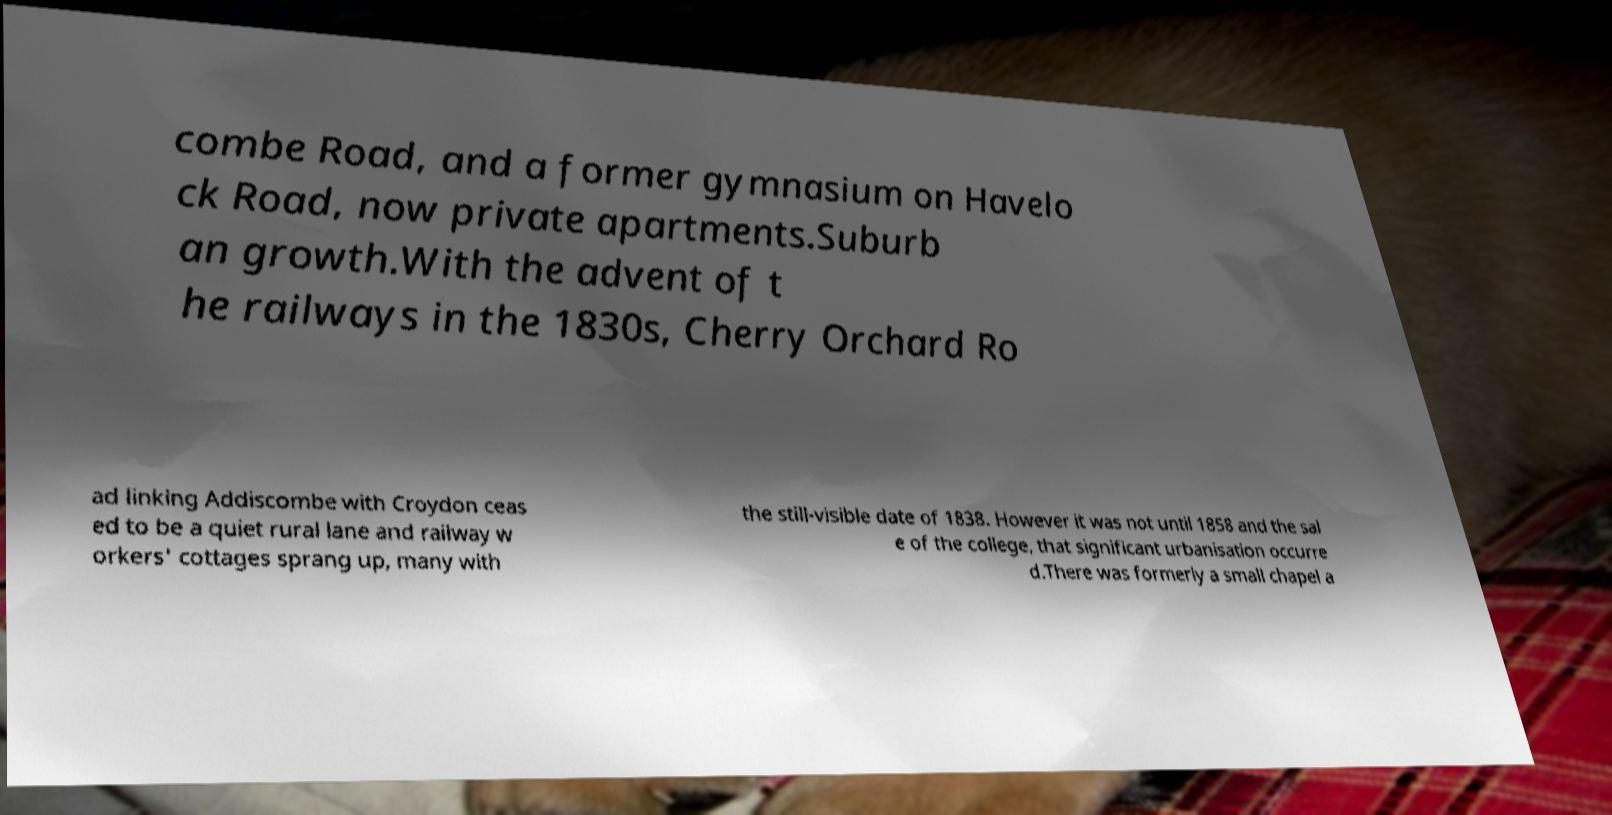For documentation purposes, I need the text within this image transcribed. Could you provide that? combe Road, and a former gymnasium on Havelo ck Road, now private apartments.Suburb an growth.With the advent of t he railways in the 1830s, Cherry Orchard Ro ad linking Addiscombe with Croydon ceas ed to be a quiet rural lane and railway w orkers' cottages sprang up, many with the still-visible date of 1838. However it was not until 1858 and the sal e of the college, that significant urbanisation occurre d.There was formerly a small chapel a 